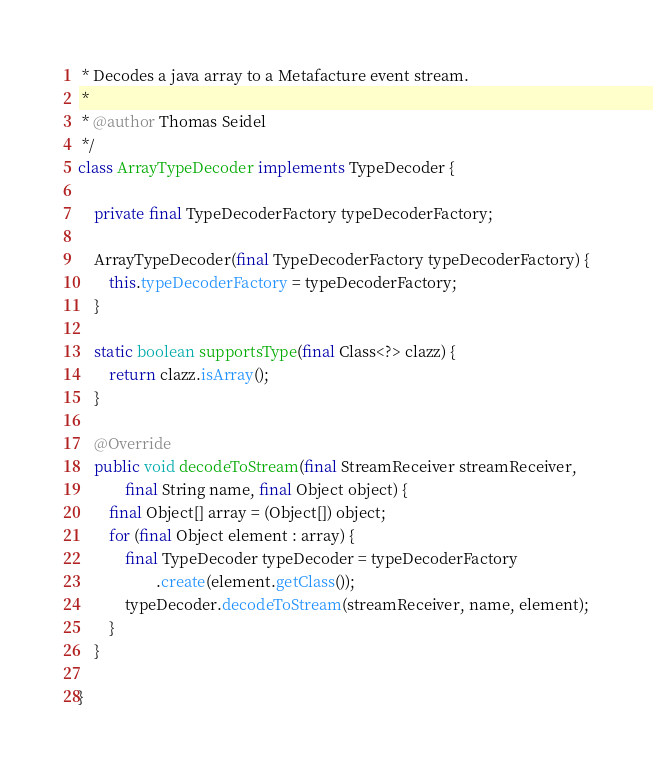<code> <loc_0><loc_0><loc_500><loc_500><_Java_> * Decodes a java array to a Metafacture event stream.
 *
 * @author Thomas Seidel
 */
class ArrayTypeDecoder implements TypeDecoder {

    private final TypeDecoderFactory typeDecoderFactory;

    ArrayTypeDecoder(final TypeDecoderFactory typeDecoderFactory) {
        this.typeDecoderFactory = typeDecoderFactory;
    }

    static boolean supportsType(final Class<?> clazz) {
        return clazz.isArray();
    }

    @Override
    public void decodeToStream(final StreamReceiver streamReceiver,
            final String name, final Object object) {
        final Object[] array = (Object[]) object;
        for (final Object element : array) {
            final TypeDecoder typeDecoder = typeDecoderFactory
                    .create(element.getClass());
            typeDecoder.decodeToStream(streamReceiver, name, element);
        }
    }

}
</code> 